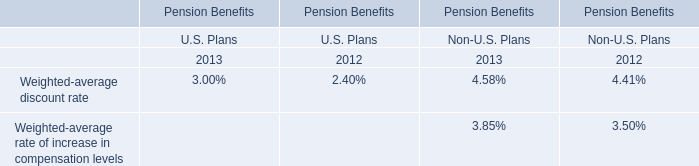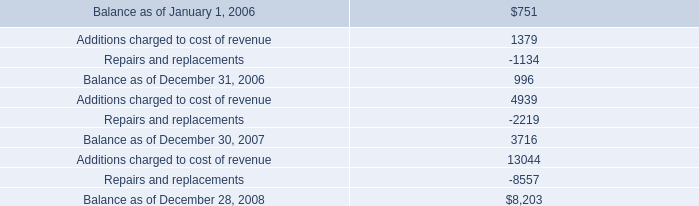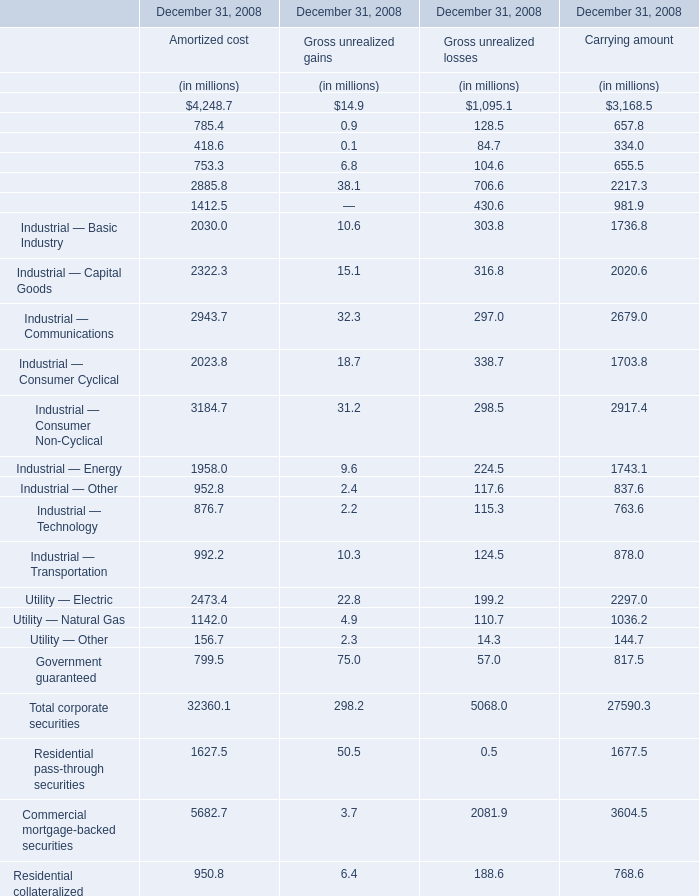Which element makes up more than 10 % of the total for Gross unrealized gains in 2008? 
Answer: Government guaranteed, Residential pass-through securities. What's the average of States and political subdivisions of December 31, 2008 Amortized cost, and Balance as of December 28, 2008 ? 
Computations: ((2113.8 + 8203.0) / 2)
Answer: 5158.4. What was the total amount of Industrial — Capital Goods, Industrial — Communications, Industrial — Consumer Cyclical and Industrial — Consumer Non-Cyclical for Gross unrealized losses? (in million) 
Computations: (((316.8 + 297) + 338.7) + 298.5)
Answer: 1251.0. 